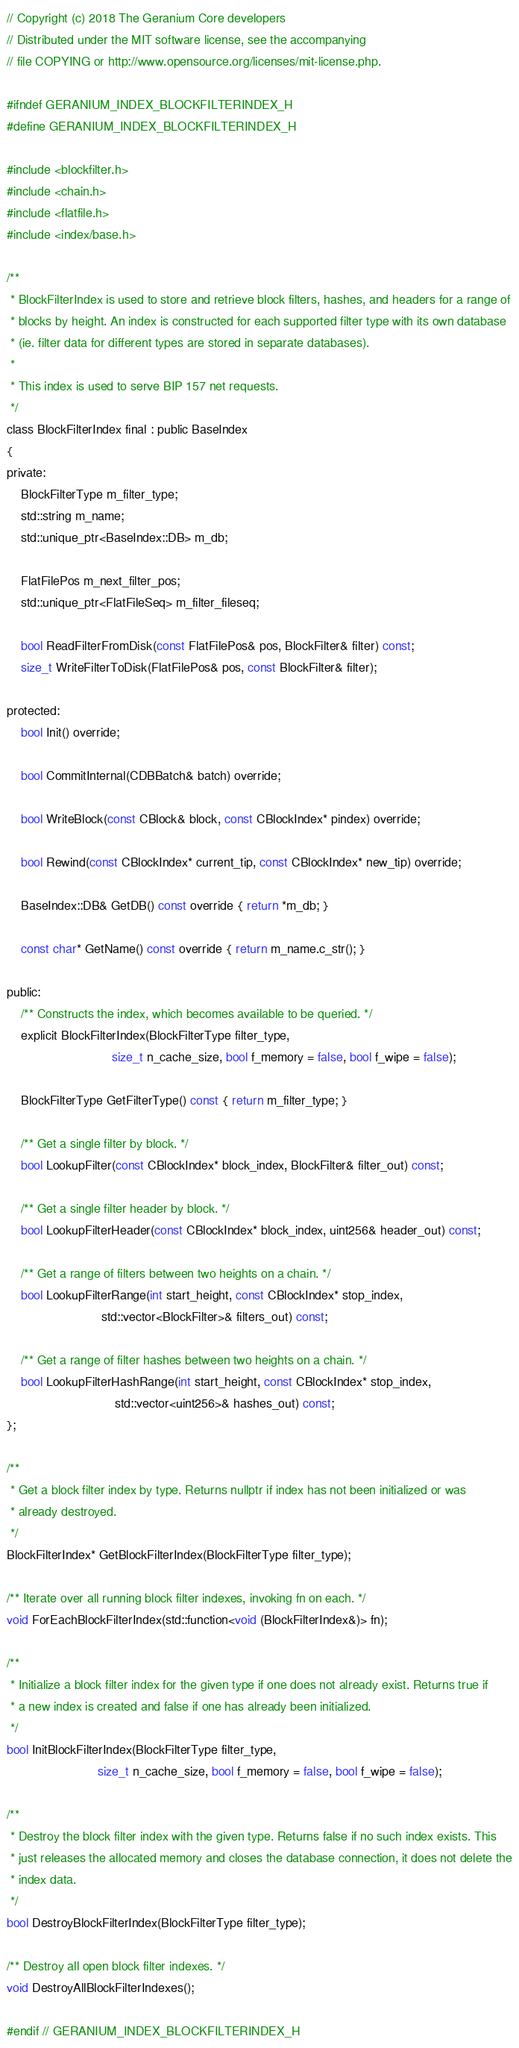<code> <loc_0><loc_0><loc_500><loc_500><_C_>// Copyright (c) 2018 The Geranium Core developers
// Distributed under the MIT software license, see the accompanying
// file COPYING or http://www.opensource.org/licenses/mit-license.php.

#ifndef GERANIUM_INDEX_BLOCKFILTERINDEX_H
#define GERANIUM_INDEX_BLOCKFILTERINDEX_H

#include <blockfilter.h>
#include <chain.h>
#include <flatfile.h>
#include <index/base.h>

/**
 * BlockFilterIndex is used to store and retrieve block filters, hashes, and headers for a range of
 * blocks by height. An index is constructed for each supported filter type with its own database
 * (ie. filter data for different types are stored in separate databases).
 *
 * This index is used to serve BIP 157 net requests.
 */
class BlockFilterIndex final : public BaseIndex
{
private:
    BlockFilterType m_filter_type;
    std::string m_name;
    std::unique_ptr<BaseIndex::DB> m_db;

    FlatFilePos m_next_filter_pos;
    std::unique_ptr<FlatFileSeq> m_filter_fileseq;

    bool ReadFilterFromDisk(const FlatFilePos& pos, BlockFilter& filter) const;
    size_t WriteFilterToDisk(FlatFilePos& pos, const BlockFilter& filter);

protected:
    bool Init() override;

    bool CommitInternal(CDBBatch& batch) override;

    bool WriteBlock(const CBlock& block, const CBlockIndex* pindex) override;

    bool Rewind(const CBlockIndex* current_tip, const CBlockIndex* new_tip) override;

    BaseIndex::DB& GetDB() const override { return *m_db; }

    const char* GetName() const override { return m_name.c_str(); }

public:
    /** Constructs the index, which becomes available to be queried. */
    explicit BlockFilterIndex(BlockFilterType filter_type,
                              size_t n_cache_size, bool f_memory = false, bool f_wipe = false);

    BlockFilterType GetFilterType() const { return m_filter_type; }

    /** Get a single filter by block. */
    bool LookupFilter(const CBlockIndex* block_index, BlockFilter& filter_out) const;

    /** Get a single filter header by block. */
    bool LookupFilterHeader(const CBlockIndex* block_index, uint256& header_out) const;

    /** Get a range of filters between two heights on a chain. */
    bool LookupFilterRange(int start_height, const CBlockIndex* stop_index,
                           std::vector<BlockFilter>& filters_out) const;

    /** Get a range of filter hashes between two heights on a chain. */
    bool LookupFilterHashRange(int start_height, const CBlockIndex* stop_index,
                               std::vector<uint256>& hashes_out) const;
};

/**
 * Get a block filter index by type. Returns nullptr if index has not been initialized or was
 * already destroyed.
 */
BlockFilterIndex* GetBlockFilterIndex(BlockFilterType filter_type);

/** Iterate over all running block filter indexes, invoking fn on each. */
void ForEachBlockFilterIndex(std::function<void (BlockFilterIndex&)> fn);

/**
 * Initialize a block filter index for the given type if one does not already exist. Returns true if
 * a new index is created and false if one has already been initialized.
 */
bool InitBlockFilterIndex(BlockFilterType filter_type,
                          size_t n_cache_size, bool f_memory = false, bool f_wipe = false);

/**
 * Destroy the block filter index with the given type. Returns false if no such index exists. This
 * just releases the allocated memory and closes the database connection, it does not delete the
 * index data.
 */
bool DestroyBlockFilterIndex(BlockFilterType filter_type);

/** Destroy all open block filter indexes. */
void DestroyAllBlockFilterIndexes();

#endif // GERANIUM_INDEX_BLOCKFILTERINDEX_H
</code> 